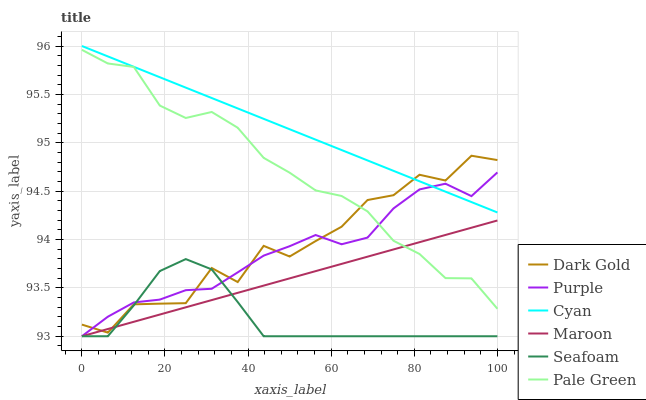Does Seafoam have the minimum area under the curve?
Answer yes or no. Yes. Does Cyan have the maximum area under the curve?
Answer yes or no. Yes. Does Purple have the minimum area under the curve?
Answer yes or no. No. Does Purple have the maximum area under the curve?
Answer yes or no. No. Is Cyan the smoothest?
Answer yes or no. Yes. Is Dark Gold the roughest?
Answer yes or no. Yes. Is Purple the smoothest?
Answer yes or no. No. Is Purple the roughest?
Answer yes or no. No. Does Purple have the lowest value?
Answer yes or no. Yes. Does Pale Green have the lowest value?
Answer yes or no. No. Does Cyan have the highest value?
Answer yes or no. Yes. Does Purple have the highest value?
Answer yes or no. No. Is Maroon less than Cyan?
Answer yes or no. Yes. Is Cyan greater than Seafoam?
Answer yes or no. Yes. Does Cyan intersect Dark Gold?
Answer yes or no. Yes. Is Cyan less than Dark Gold?
Answer yes or no. No. Is Cyan greater than Dark Gold?
Answer yes or no. No. Does Maroon intersect Cyan?
Answer yes or no. No. 